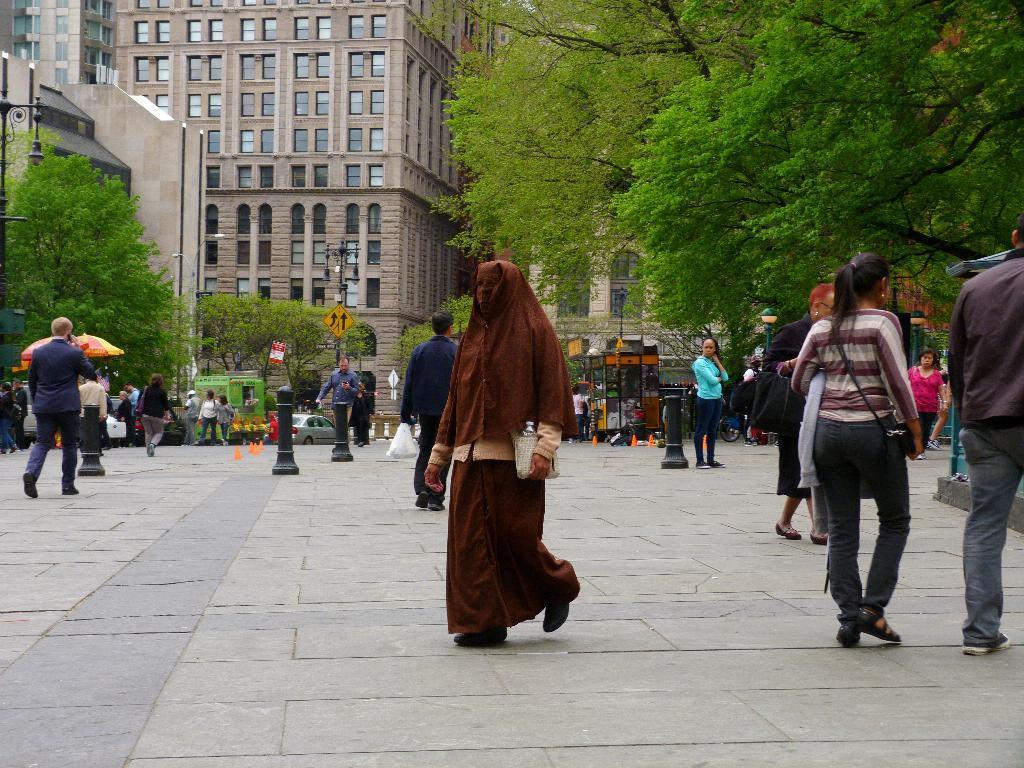Could you give a brief overview of what you see in this image? In this image we can see group of persons are standing on the ground, there are buildings, there is a window glass, there are trees, there is a sign board, there is a pole, there are cars travelling on the road. 